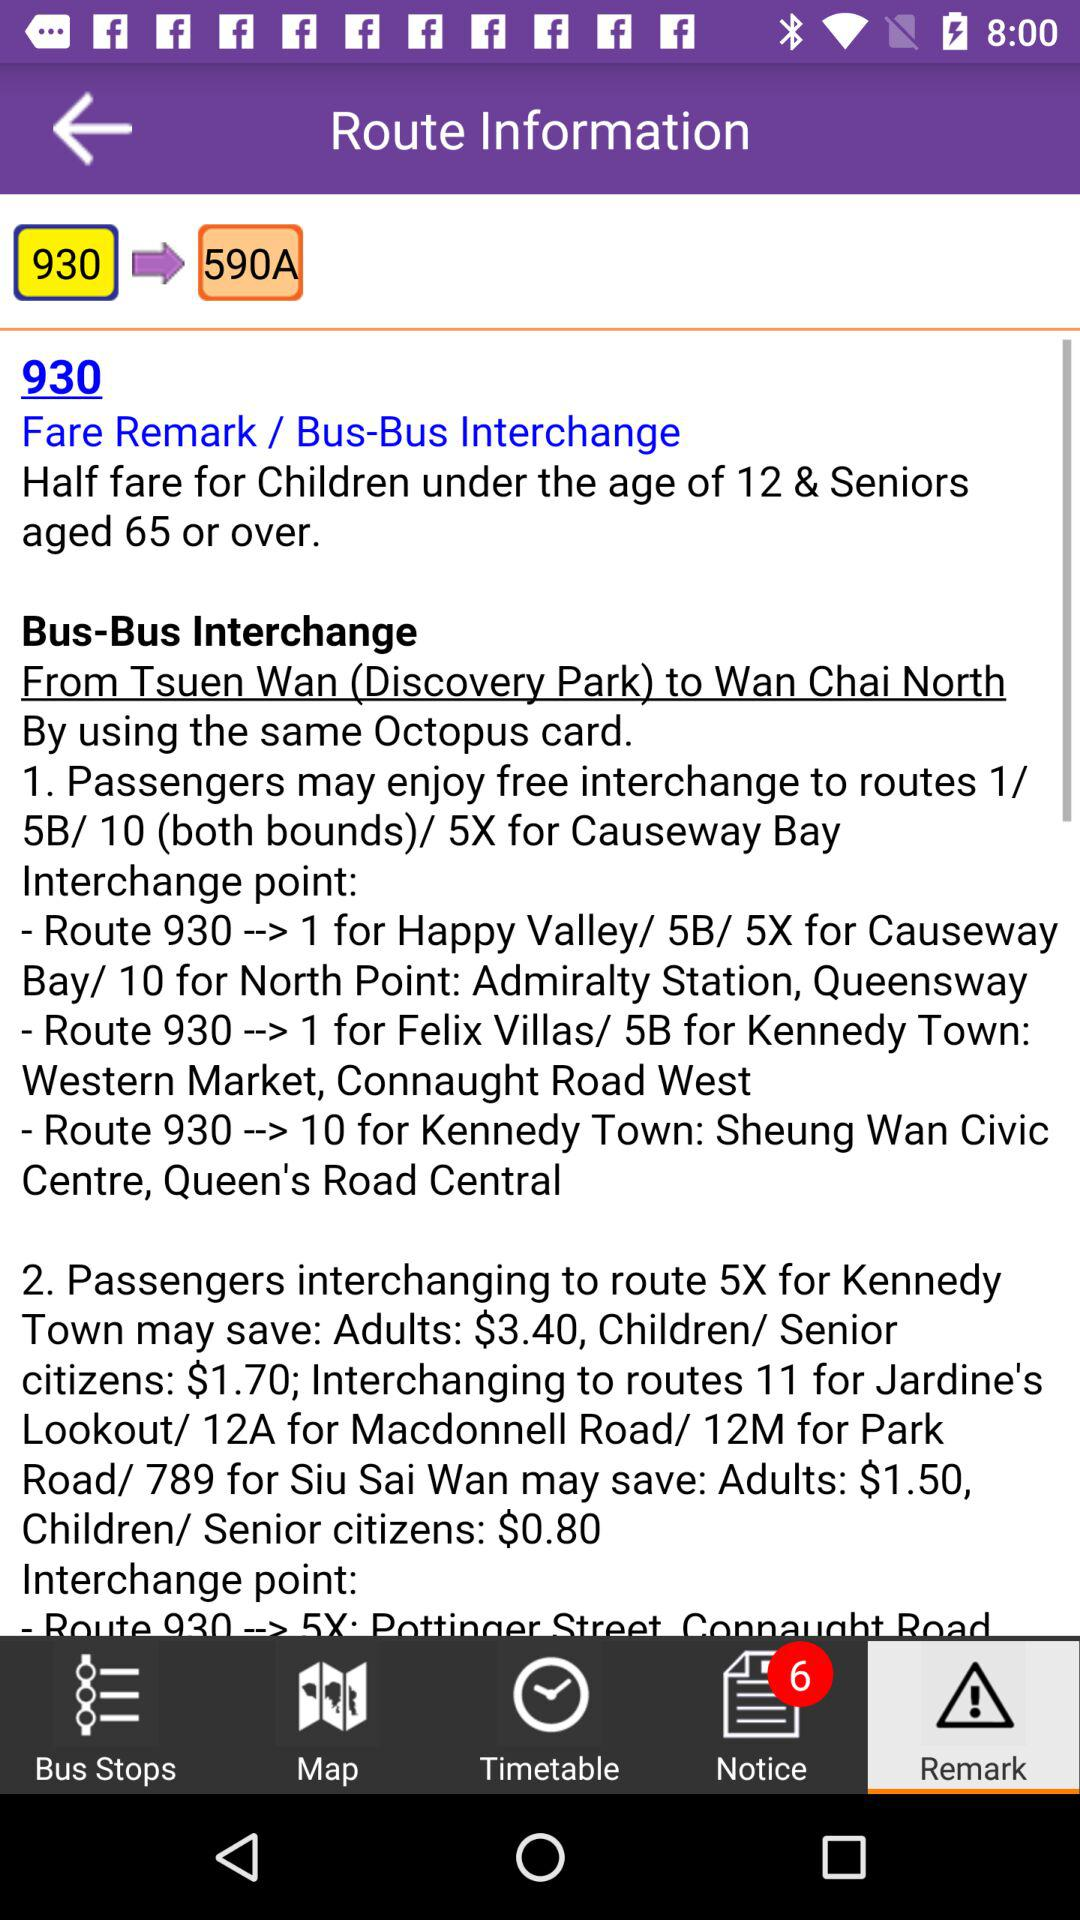What is the number of new notifications in "Notice"? The number of new notifications in "Notice" is 6. 